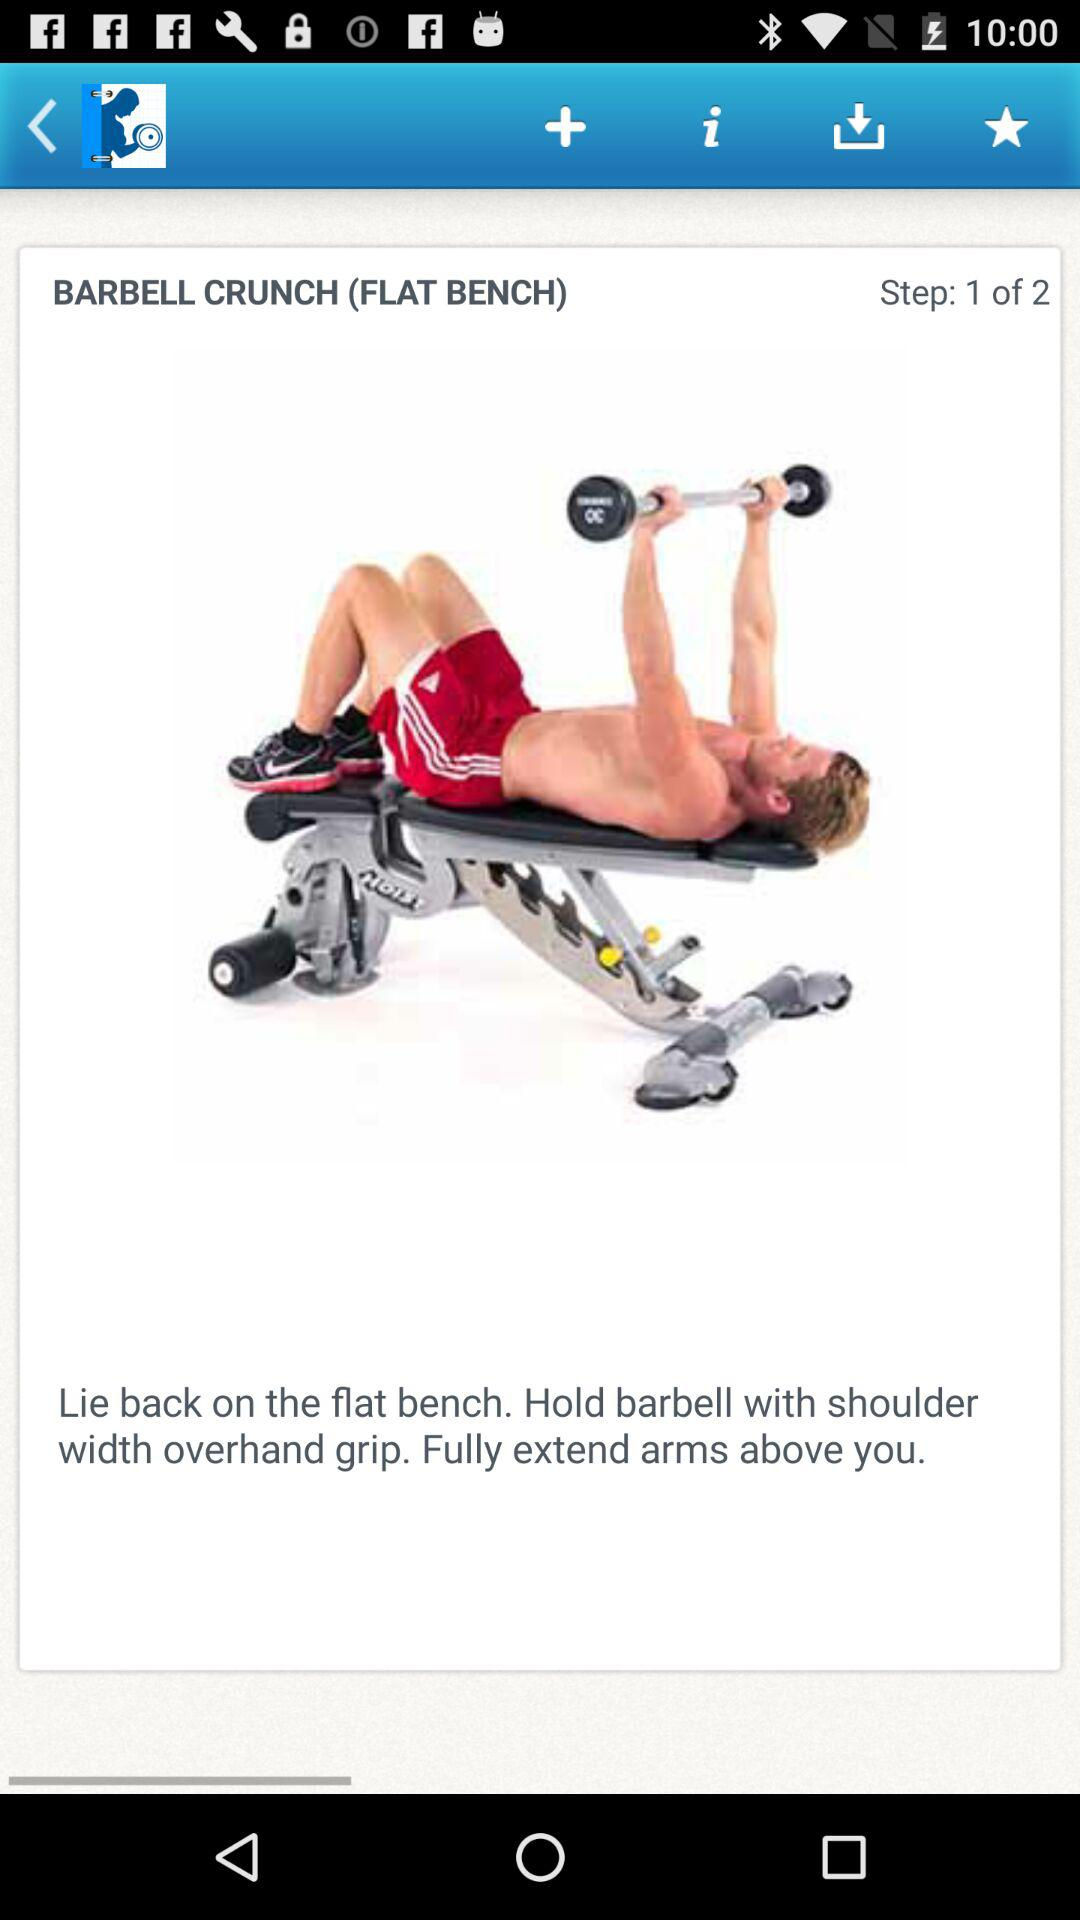Which step is this? This is step 1. 